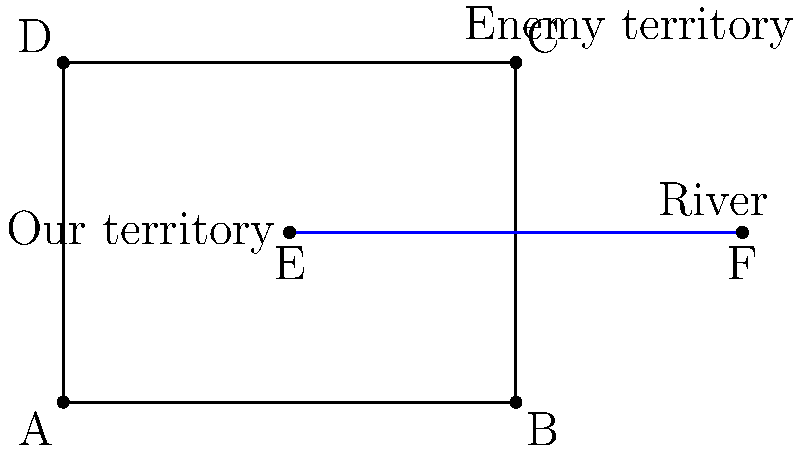In planning a pincer attack, we need to reflect our troop movements across the river. If our main force is at point C(4,3), where should we position our flanking force on the other side of the river to create a perfect pincer movement? Give the coordinates of point G, which is the reflection of C across the river line EF. To find the reflection of point C across the river line EF, we can follow these steps:

1) The river line EF can be represented by the equation $y = 1.5$, as it's a horizontal line passing through points E(2,1.5) and F(6,1.5).

2) To reflect point C(4,3) across this line:
   a) Find the perpendicular distance from C to the line: $3 - 1.5 = 1.5$
   b) Double this distance: $1.5 * 2 = 3$
   c) Subtract this from the y-coordinate of C: $3 - 3 = 0$

3) The x-coordinate remains the same in a reflection across a horizontal line.

4) Therefore, the coordinates of the reflected point G are (4,0).

This positions our flanking force directly across the river from our main force, creating a symmetrical pincer movement that can trap the enemy between our two forces.
Answer: G(4,0) 